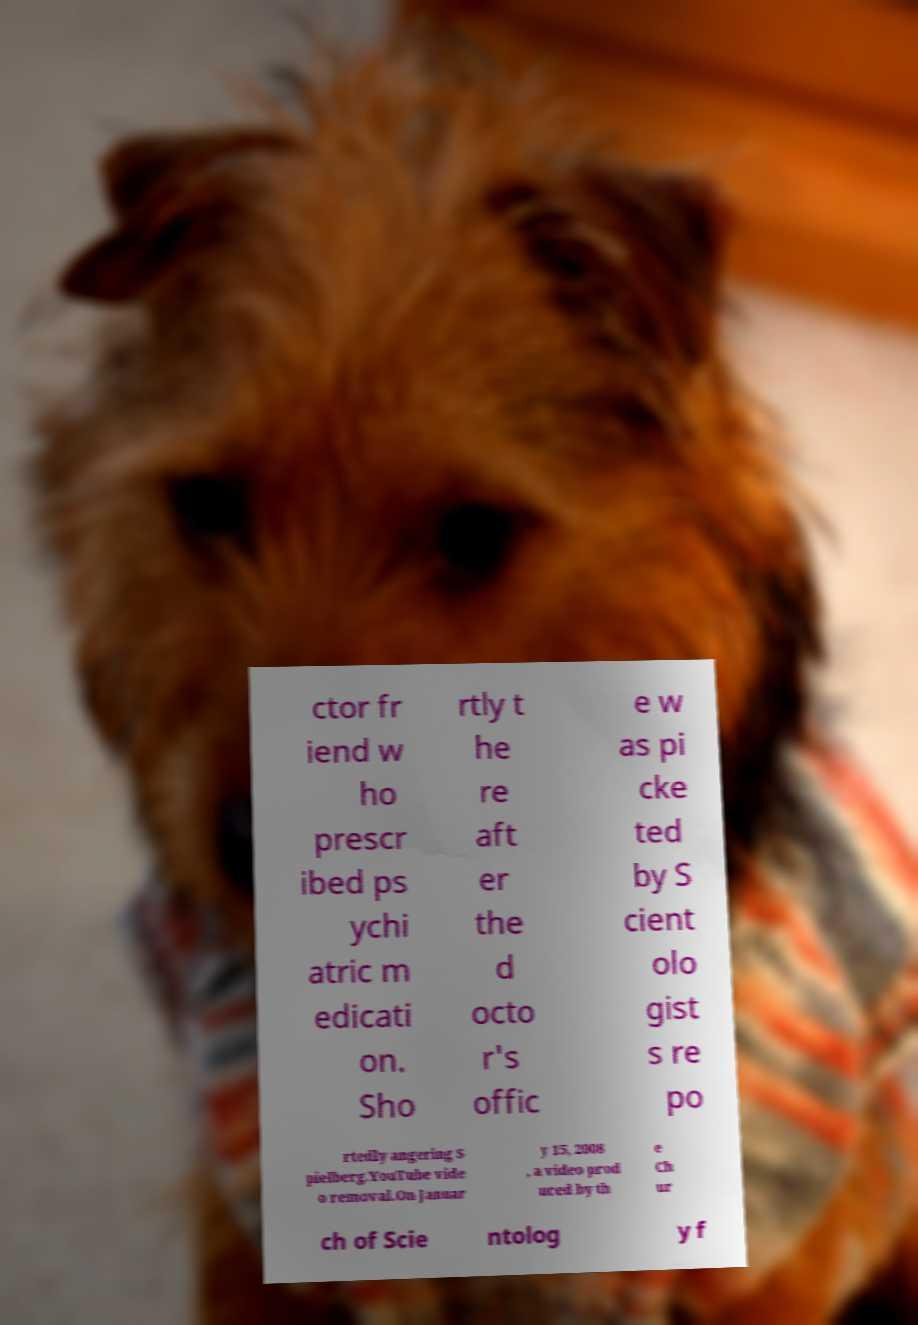There's text embedded in this image that I need extracted. Can you transcribe it verbatim? ctor fr iend w ho prescr ibed ps ychi atric m edicati on. Sho rtly t he re aft er the d octo r's offic e w as pi cke ted by S cient olo gist s re po rtedly angering S pielberg.YouTube vide o removal.On Januar y 15, 2008 , a video prod uced by th e Ch ur ch of Scie ntolog y f 